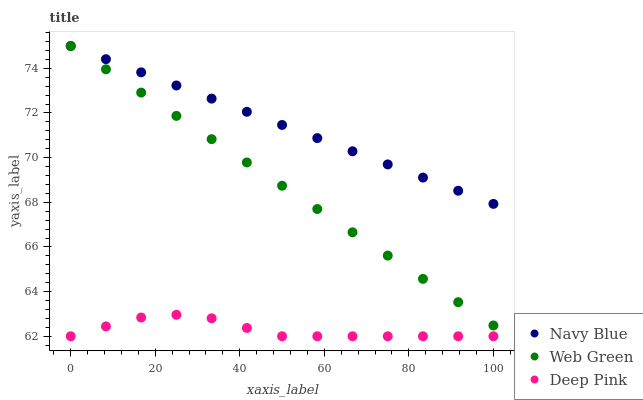Does Deep Pink have the minimum area under the curve?
Answer yes or no. Yes. Does Navy Blue have the maximum area under the curve?
Answer yes or no. Yes. Does Web Green have the minimum area under the curve?
Answer yes or no. No. Does Web Green have the maximum area under the curve?
Answer yes or no. No. Is Web Green the smoothest?
Answer yes or no. Yes. Is Deep Pink the roughest?
Answer yes or no. Yes. Is Deep Pink the smoothest?
Answer yes or no. No. Is Web Green the roughest?
Answer yes or no. No. Does Deep Pink have the lowest value?
Answer yes or no. Yes. Does Web Green have the lowest value?
Answer yes or no. No. Does Web Green have the highest value?
Answer yes or no. Yes. Does Deep Pink have the highest value?
Answer yes or no. No. Is Deep Pink less than Web Green?
Answer yes or no. Yes. Is Navy Blue greater than Deep Pink?
Answer yes or no. Yes. Does Navy Blue intersect Web Green?
Answer yes or no. Yes. Is Navy Blue less than Web Green?
Answer yes or no. No. Is Navy Blue greater than Web Green?
Answer yes or no. No. Does Deep Pink intersect Web Green?
Answer yes or no. No. 